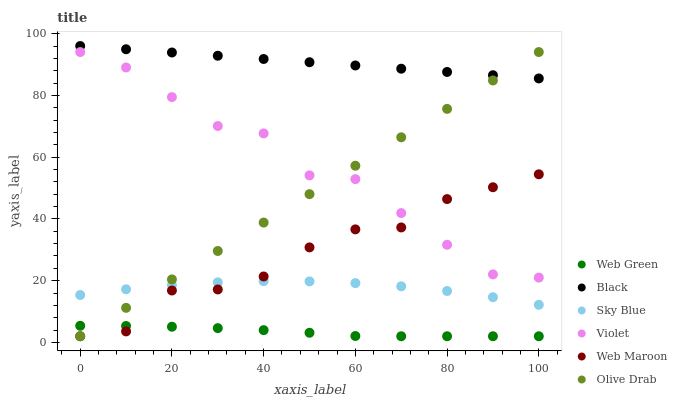Does Web Green have the minimum area under the curve?
Answer yes or no. Yes. Does Black have the maximum area under the curve?
Answer yes or no. Yes. Does Black have the minimum area under the curve?
Answer yes or no. No. Does Web Green have the maximum area under the curve?
Answer yes or no. No. Is Olive Drab the smoothest?
Answer yes or no. Yes. Is Web Maroon the roughest?
Answer yes or no. Yes. Is Web Green the smoothest?
Answer yes or no. No. Is Web Green the roughest?
Answer yes or no. No. Does Web Maroon have the lowest value?
Answer yes or no. Yes. Does Black have the lowest value?
Answer yes or no. No. Does Black have the highest value?
Answer yes or no. Yes. Does Web Green have the highest value?
Answer yes or no. No. Is Violet less than Black?
Answer yes or no. Yes. Is Black greater than Violet?
Answer yes or no. Yes. Does Black intersect Olive Drab?
Answer yes or no. Yes. Is Black less than Olive Drab?
Answer yes or no. No. Is Black greater than Olive Drab?
Answer yes or no. No. Does Violet intersect Black?
Answer yes or no. No. 